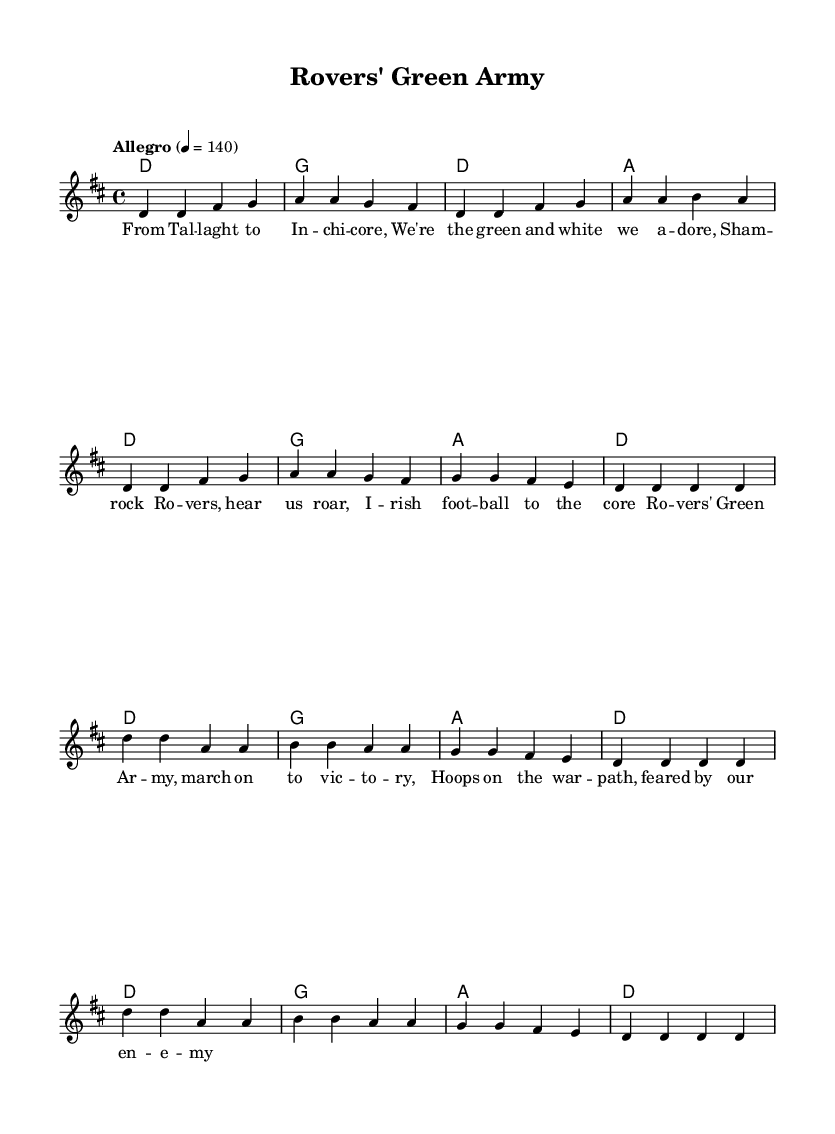What is the key signature of this music? The key signature is D major, which has two sharps (F# and C#). This can be determined by identifying the key indicated at the start of the staff where "d" is mentioned, indicating D major.
Answer: D major What is the time signature of this music? The time signature is 4/4, which is indicated at the start of the staff as well. This means there are four beats in each measure, and the quarter note receives one beat.
Answer: 4/4 What is the tempo marking for this piece? The tempo marking is "Allegro" with a metronome marking of 140 beats per minute. This indicates the piece should be played quickly and lively, which is a common characteristic of punk music.
Answer: Allegro 4 = 140 How many measures are in the chorus section? The chorus section consists of 4 measures, as each line of the chorus lyrics corresponds to one measure, and there are two lines of correlated music in the score.
Answer: 4 What is the primary theme expressed in the lyrics? The primary theme expressed in the lyrics centers around celebration and pride for the Shamrock Rovers. The lyrics evoke feelings of camaraderie and determination, which are typical in punk anthems that rally support for local football clubs.
Answer: Pride and celebration How many distinct chords are used in the verse? There are 4 distinct chords used in the verse: D, G, A. This is determined by looking at the chord symbols listed in the harmony section, where each symbol represents a different chord played in the measures.
Answer: 3 